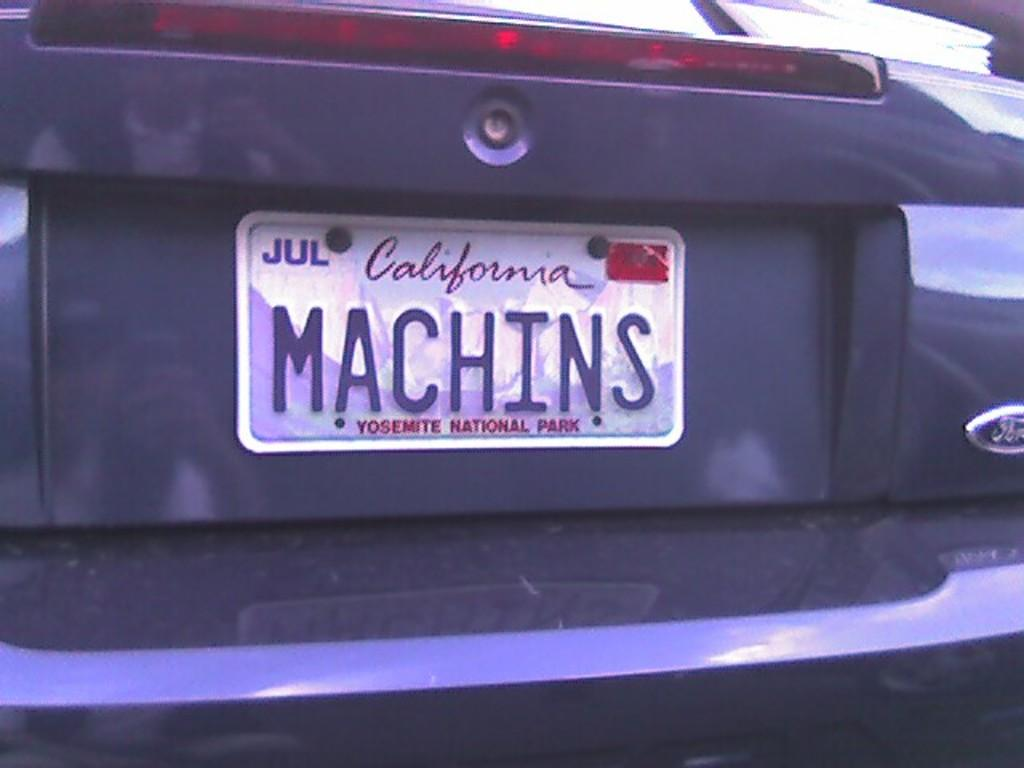<image>
Create a compact narrative representing the image presented. A California license plate with the word MACHINS on it 